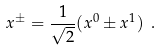<formula> <loc_0><loc_0><loc_500><loc_500>x ^ { \pm } = \frac { 1 } { \sqrt { 2 } } ( x ^ { 0 } \pm x ^ { 1 } ) \ .</formula> 